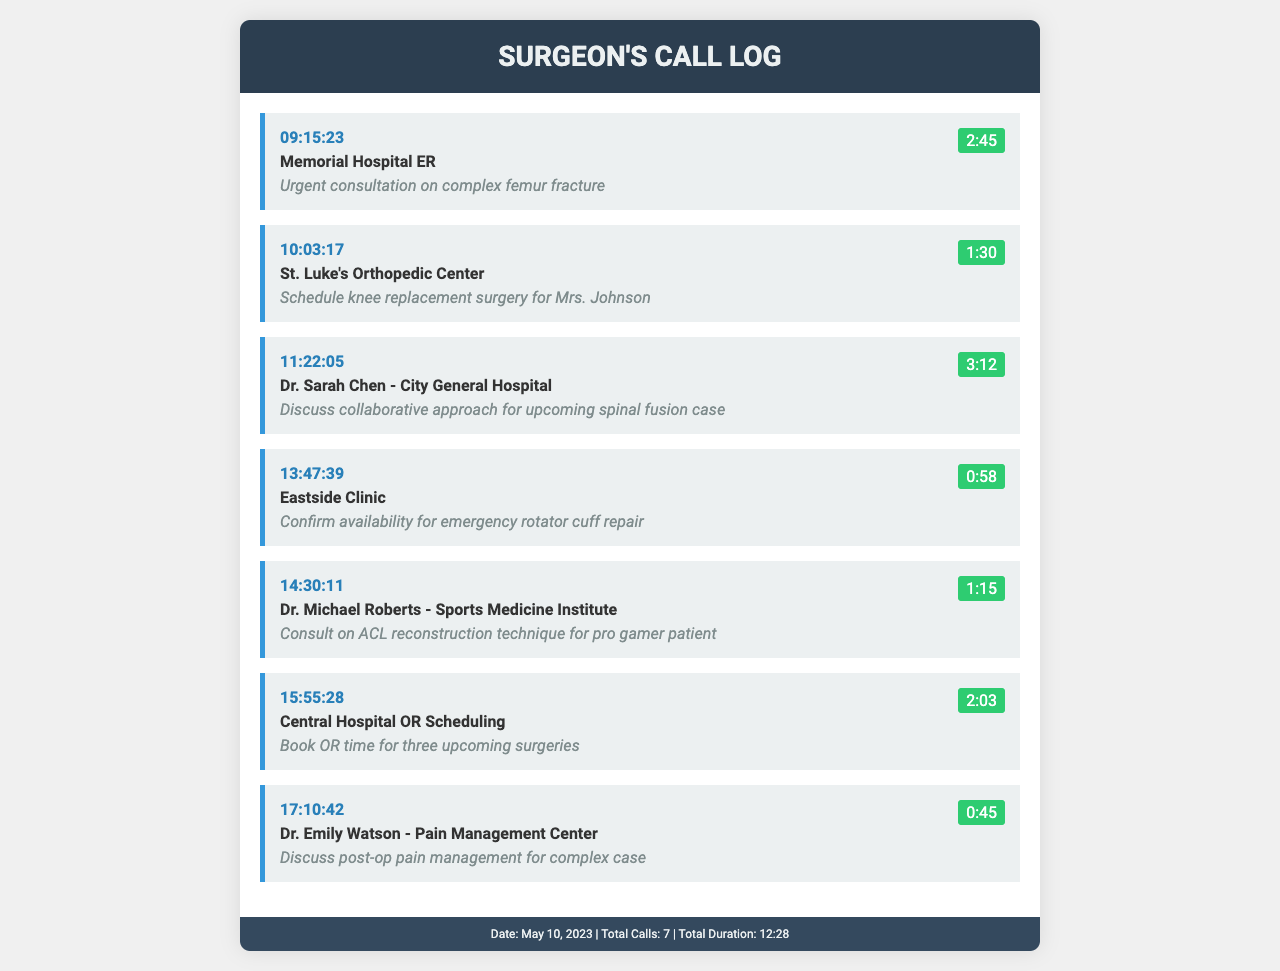What time was the call to Memorial Hospital ER? The time indicates when the call was placed to Memorial Hospital ER, which is found in the call entry.
Answer: 09:15:23 How long was the call with Dr. Sarah Chen? This requires checking the duration of the call to Dr. Sarah Chen, which is provided in the call log.
Answer: 3:12 What was the purpose of the call to Eastside Clinic? The purpose of each call is specified in the call entries, with Eastside Clinic's purpose mentioned specifically.
Answer: Confirm availability for emergency rotator cuff repair Which hospital was contacted for scheduling surgery for Mrs. Johnson? The call entry outlines the contact for scheduling surgery, specifically naming the hospital involved.
Answer: St. Luke's Orthopedic Center How many total calls are recorded in this log? The total number of calls is stated in the footer of the document and sums up all entries.
Answer: 7 What was the call duration for the last entry? The duration of each call is noted in the entries, requiring reference to the last one for the specific duration.
Answer: 0:45 Which doctor was consulted for the ACL reconstruction technique? The call entry specifies the doctor contacted regarding the ACL reconstruction technique inquiry.
Answer: Dr. Michael Roberts What is the total duration of all calls combined? The footer shows the total duration, which is calculated from the individual call durations listed.
Answer: 12:28 